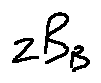Convert formula to latex. <formula><loc_0><loc_0><loc_500><loc_500>z B _ { B }</formula> 